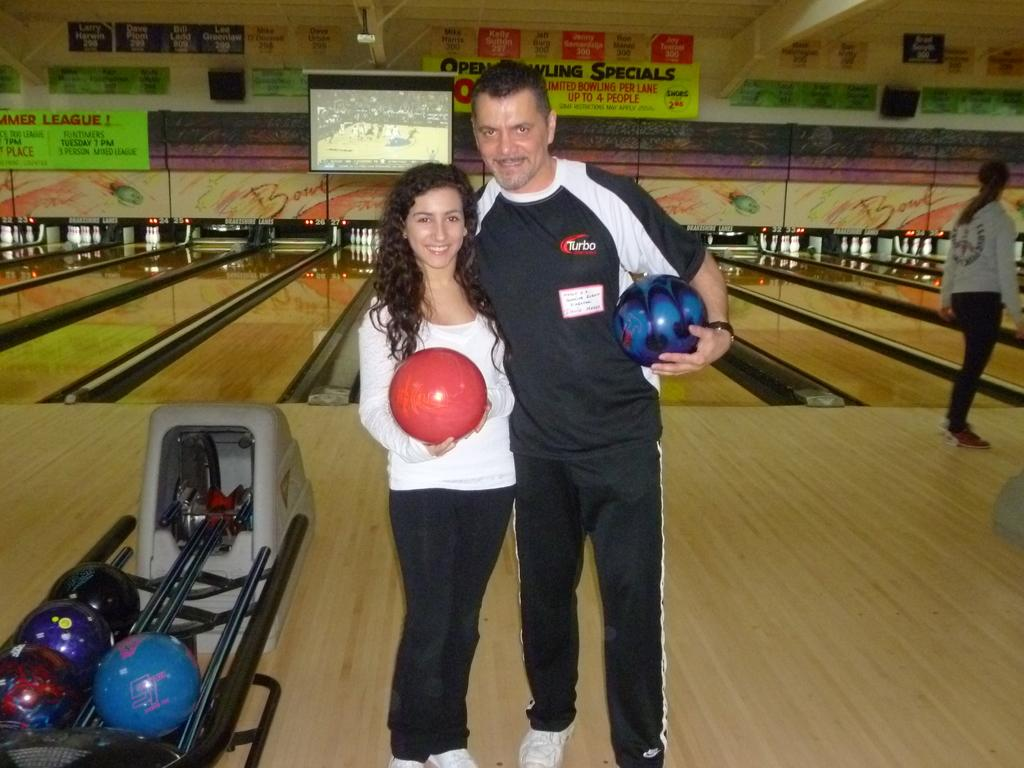<image>
Give a short and clear explanation of the subsequent image. Two people are posing at a bowling alley near a sign that says, 'Open Bowling Specials'. 